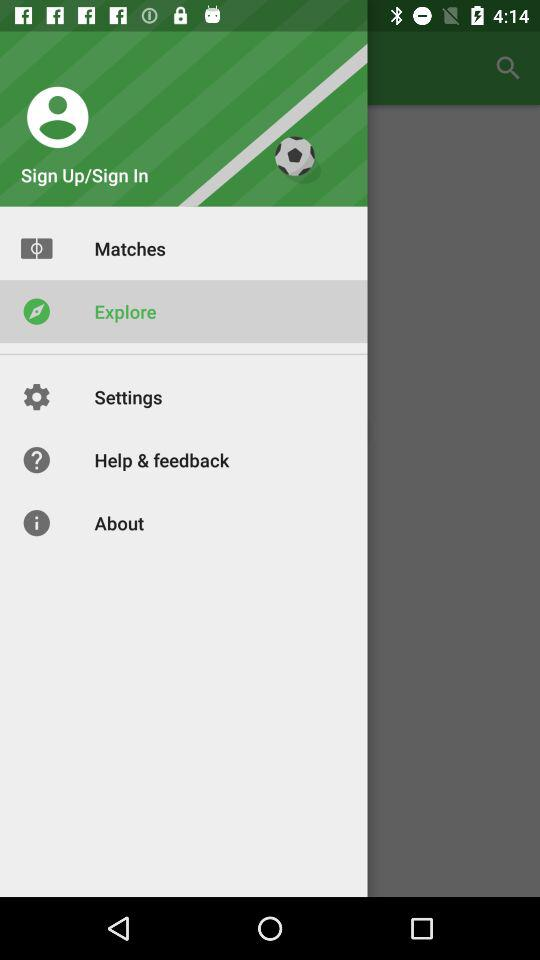When will the next match be played?
When the provided information is insufficient, respond with <no answer>. <no answer> 